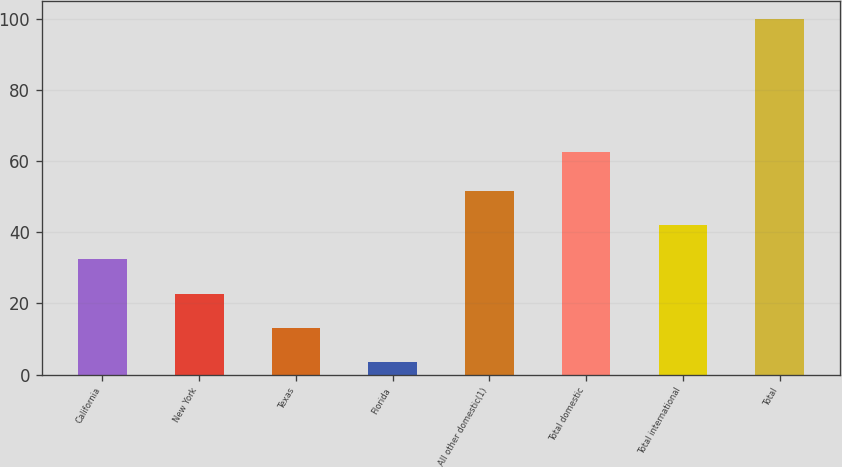Convert chart to OTSL. <chart><loc_0><loc_0><loc_500><loc_500><bar_chart><fcel>California<fcel>New York<fcel>Texas<fcel>Florida<fcel>All other domestic(1)<fcel>Total domestic<fcel>Total international<fcel>Total<nl><fcel>32.45<fcel>22.8<fcel>13.15<fcel>3.5<fcel>51.75<fcel>62.7<fcel>42.1<fcel>100<nl></chart> 